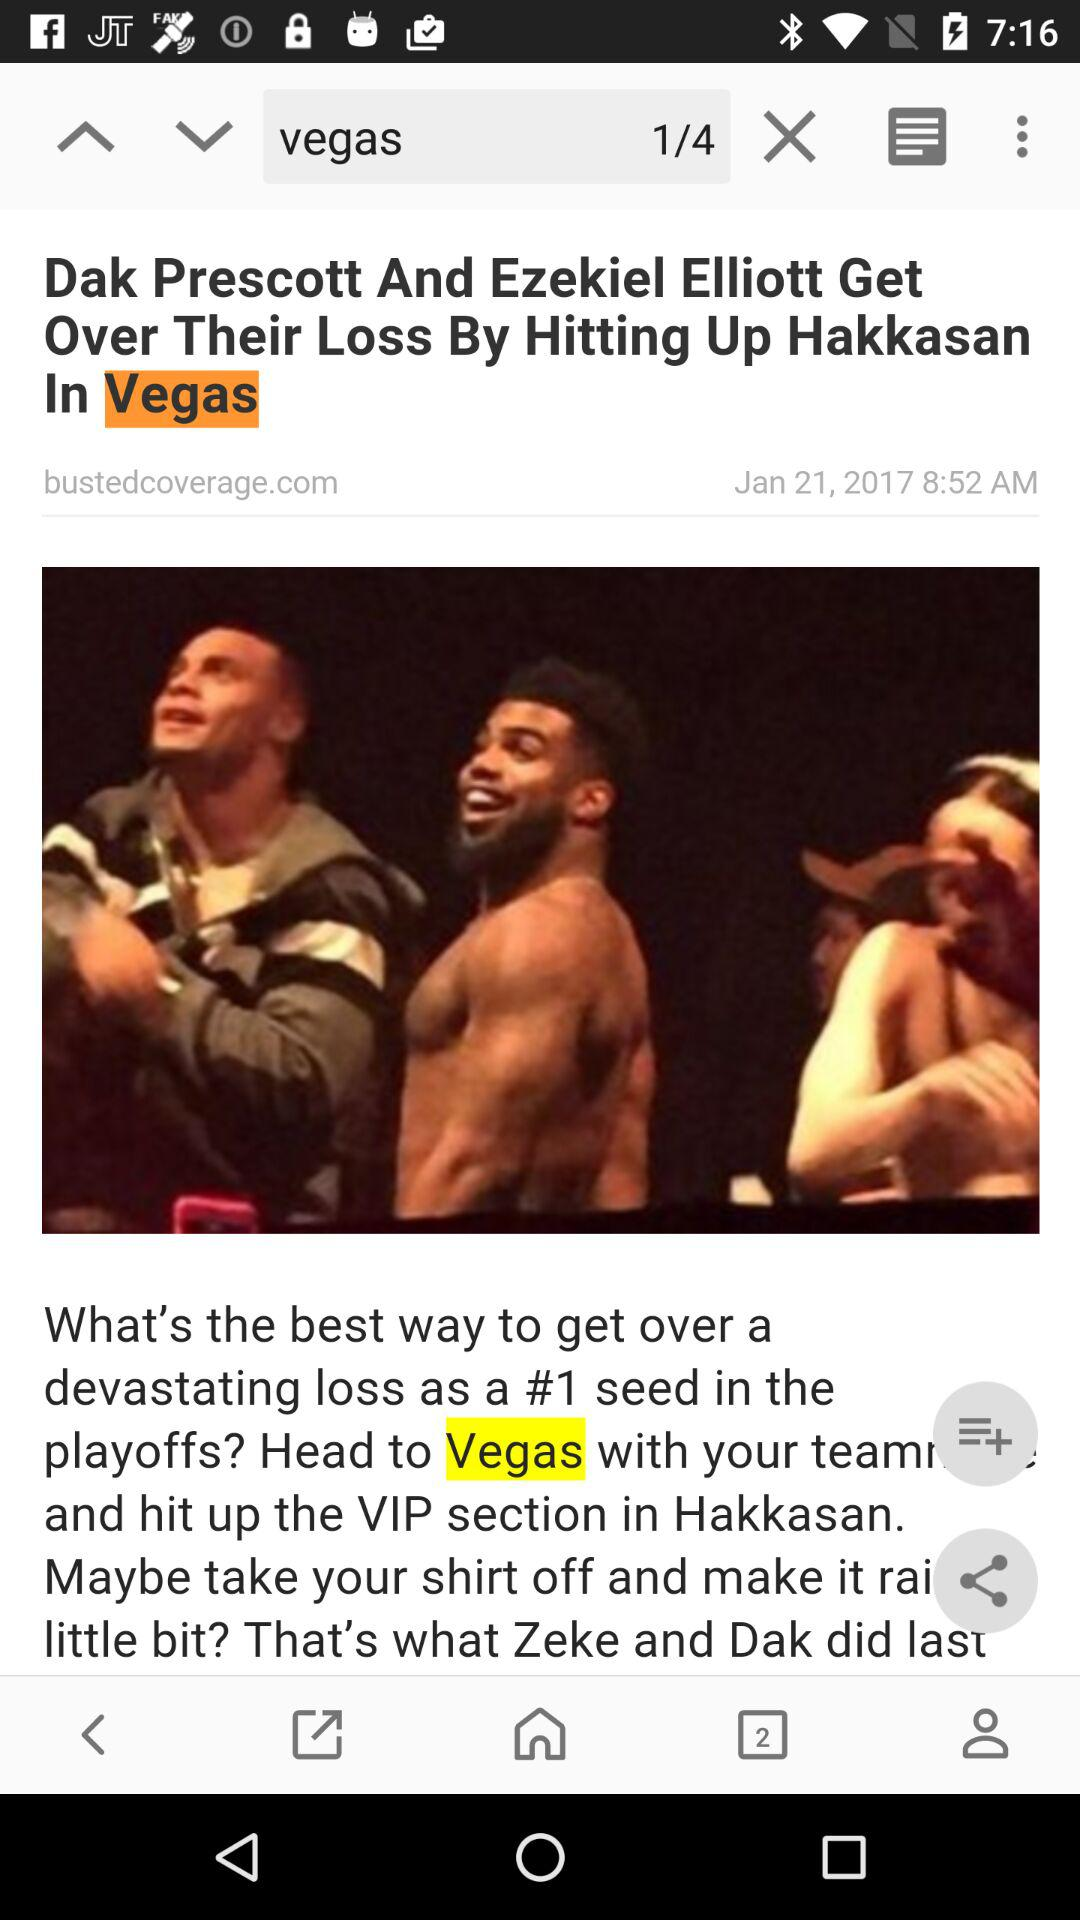At what time was the article posted? The article was posted at 8:52 AM. 